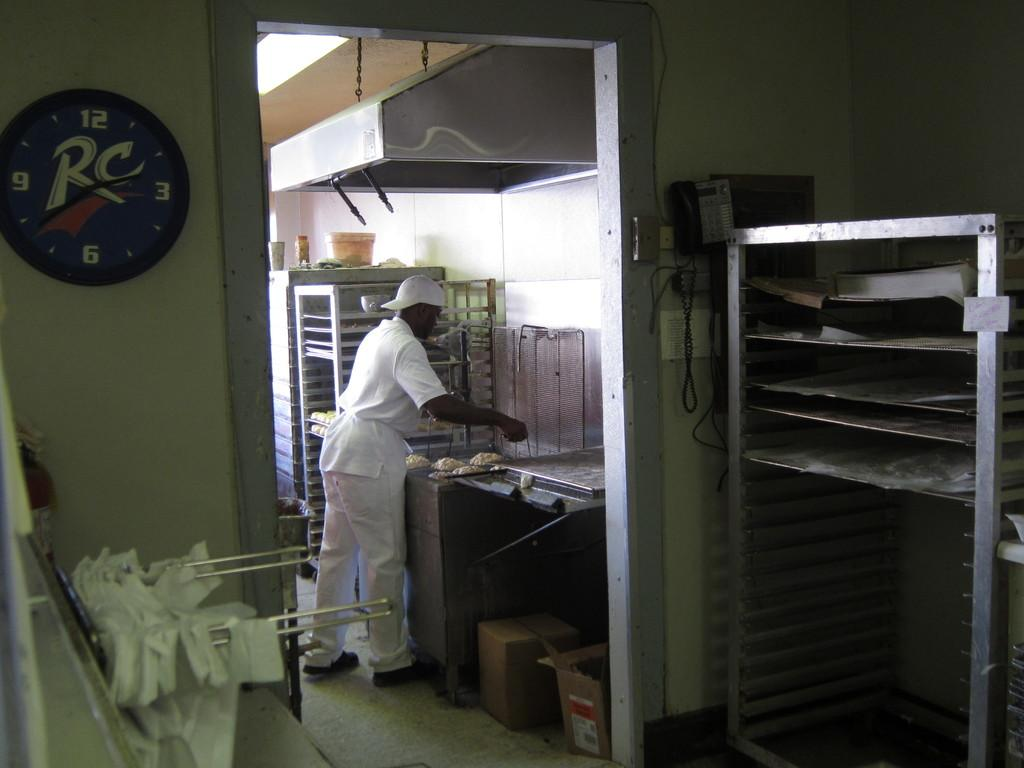<image>
Provide a brief description of the given image. the letters RC are on the clock next to the kitchen 